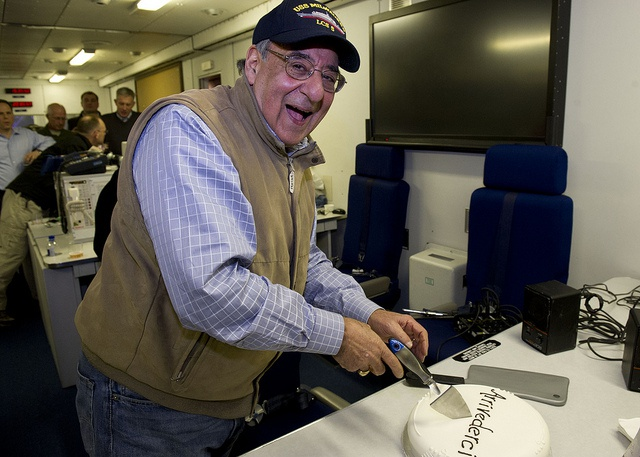Describe the objects in this image and their specific colors. I can see people in black, gray, and darkgray tones, tv in black, darkgreen, gray, and olive tones, chair in black, gray, navy, and darkgray tones, chair in black, gray, darkgreen, and tan tones, and cake in black, beige, darkgray, and gray tones in this image. 